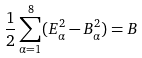<formula> <loc_0><loc_0><loc_500><loc_500>\frac { 1 } { 2 } \sum _ { \alpha = 1 } ^ { 8 } ( E _ { \alpha } ^ { 2 } - B _ { \alpha } ^ { 2 } ) = B</formula> 